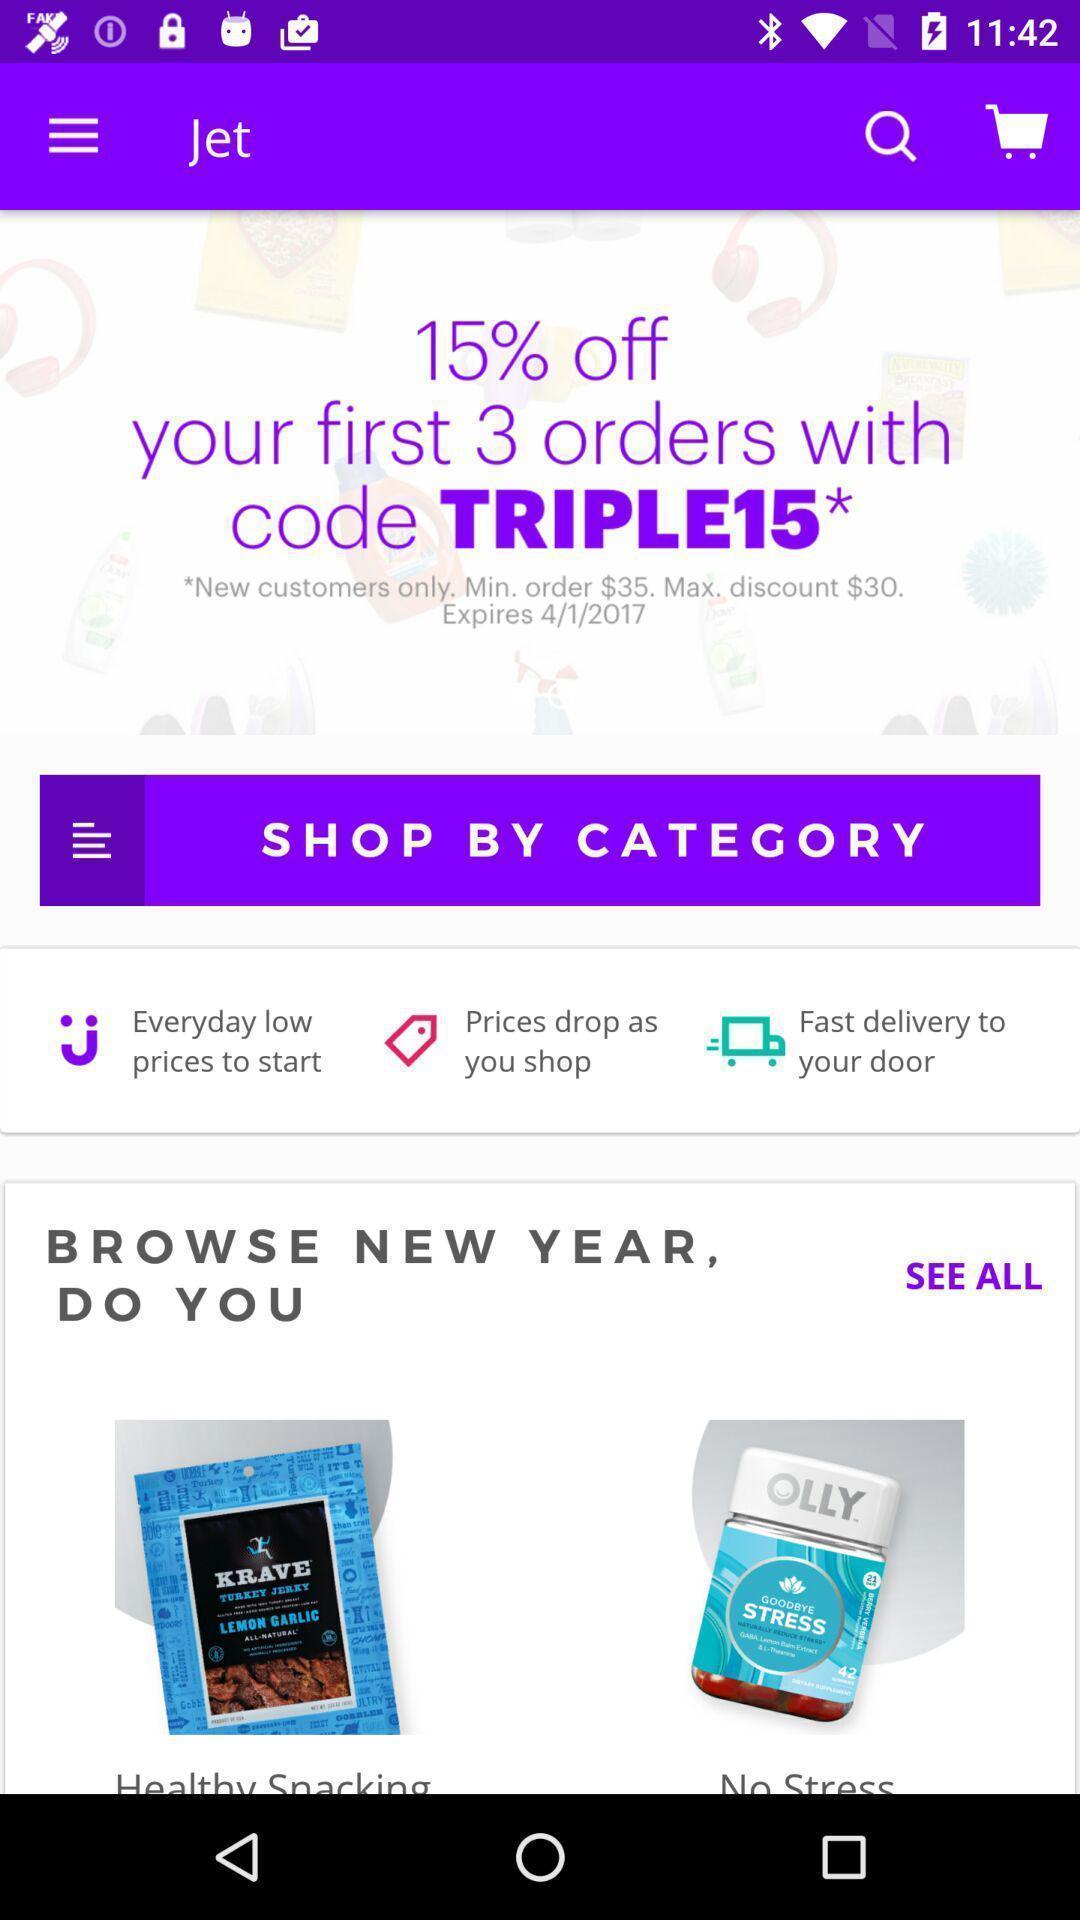Provide a description of this screenshot. Page displaying to shop by category in shopping app. 